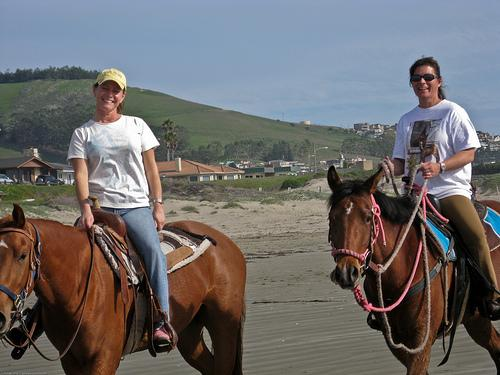Which objects in the image have to do with horses and their equipment? Horse heads, horse ears, horse noses, bridles, saddles, reins, blankets, and harnesses are all objects related to horses and their equipment. Describe the landscape that surrounds the individuals in the image. The landscape features dark green trees atop a long sloping hill, and a parked black Subaru nearby. How many horses are in the image, and who is riding them? There are two horses in the image, each being ridden by a woman. What emotions are displayed by the women riding the horses? Both women are smiling while riding the horses. What type of interaction is happening between the women and their horses? The women are engaging in a horseback riding activity and seem to be enjoying themselves. Count the number of women and identify their accessories in the image. There are two women, one wearing a cap and sunglasses while riding her horse, and the other wearing a hat and watch on her left wrist. What kinds of houses can be seen in the image? There's a grouping of small residential homes, a one-story house with a red roof, and a house with a black roof. Briefly describe the outfits the women are wearing while riding the horses. One woman is wearing a white tee shirt, light blue denim pants, and a pale yellow baseball cap. The other woman is wearing a white tee shirt, jeans, and black sunglasses with oval lenses. What are the characteristics of the horses and their equipment? The horses are short-haired and brown, wearing saddles and pink harnesses. They also have bridles and pink reins. Identify the non-human subjects in the image and their relation to the main subjects. The non-human subjects are the horses, which are being ridden by the main subjects (the two women), dark green trees, residential homes, and a parked black Subaru. 